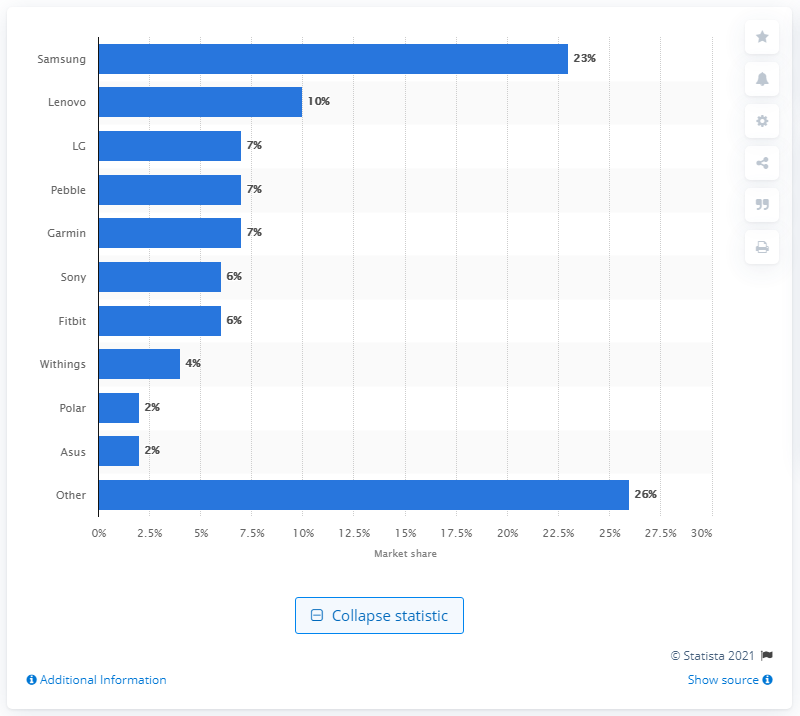List a handful of essential elements in this visual. In 2014, Samsung held a 23% share of the global smartwatch market. In 2014, Samsung held a significant 23% share of the global smartwatch market. 